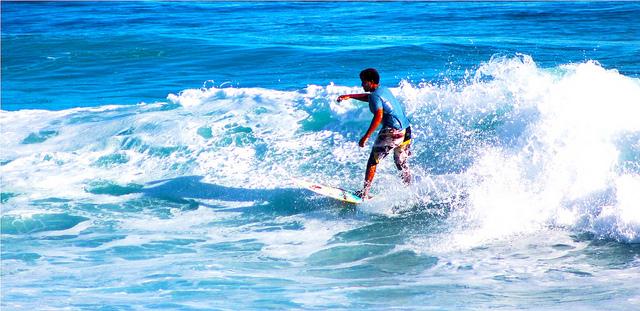Is this a big wave?
Give a very brief answer. No. What is the man doing on the water?
Answer briefly. Surfing. What is the man wearing?
Concise answer only. Wetsuit. Is the man going to ski down the mountain?
Write a very short answer. No. How many people are riding boards?
Quick response, please. 1. What color is the water?
Concise answer only. Blue. Is this boy in beachwear?
Keep it brief. Yes. Is this man a professional water surfer?
Be succinct. No. Which hand is the man holding up?
Write a very short answer. Right. 